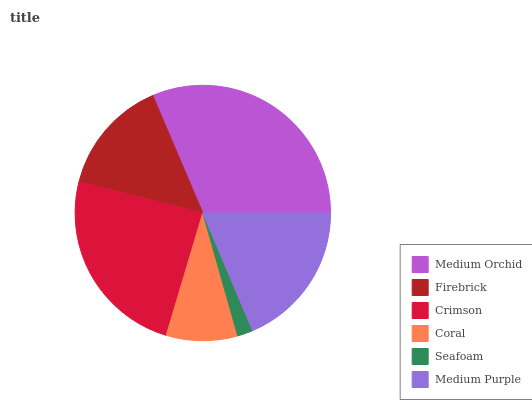Is Seafoam the minimum?
Answer yes or no. Yes. Is Medium Orchid the maximum?
Answer yes or no. Yes. Is Firebrick the minimum?
Answer yes or no. No. Is Firebrick the maximum?
Answer yes or no. No. Is Medium Orchid greater than Firebrick?
Answer yes or no. Yes. Is Firebrick less than Medium Orchid?
Answer yes or no. Yes. Is Firebrick greater than Medium Orchid?
Answer yes or no. No. Is Medium Orchid less than Firebrick?
Answer yes or no. No. Is Medium Purple the high median?
Answer yes or no. Yes. Is Firebrick the low median?
Answer yes or no. Yes. Is Crimson the high median?
Answer yes or no. No. Is Medium Purple the low median?
Answer yes or no. No. 